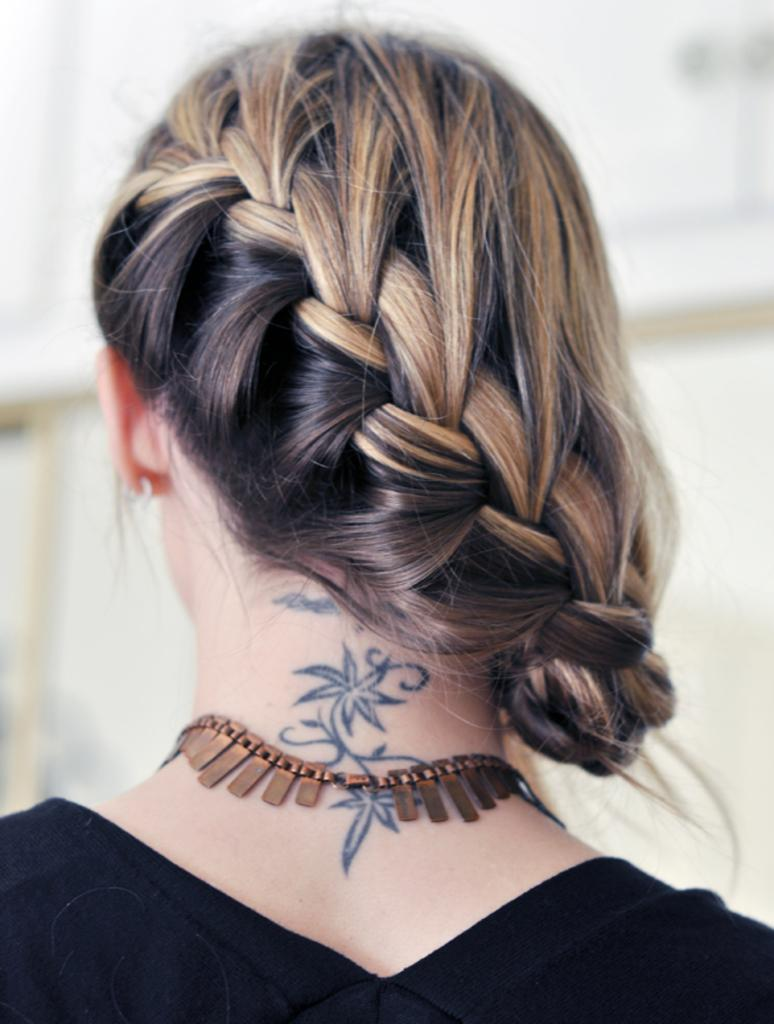Who is the main subject in the image? There is a woman in the image. Can you describe the woman's hairstyle? The woman has a hairstyle, but the specific style cannot be determined from the image. What is visible on the woman's neck? There is a tattoo on the woman's neck. What type of jewelry is the woman wearing? The woman is wearing a necklace. What color is the woman's T-shirt? The woman is wearing a black T-shirt. How would you describe the background of the image? The background of the image appears blurry. What type of camping equipment can be seen in the image? There is no camping equipment present in the image. Is there a fireman visible in the image? There is no fireman present in the image. 